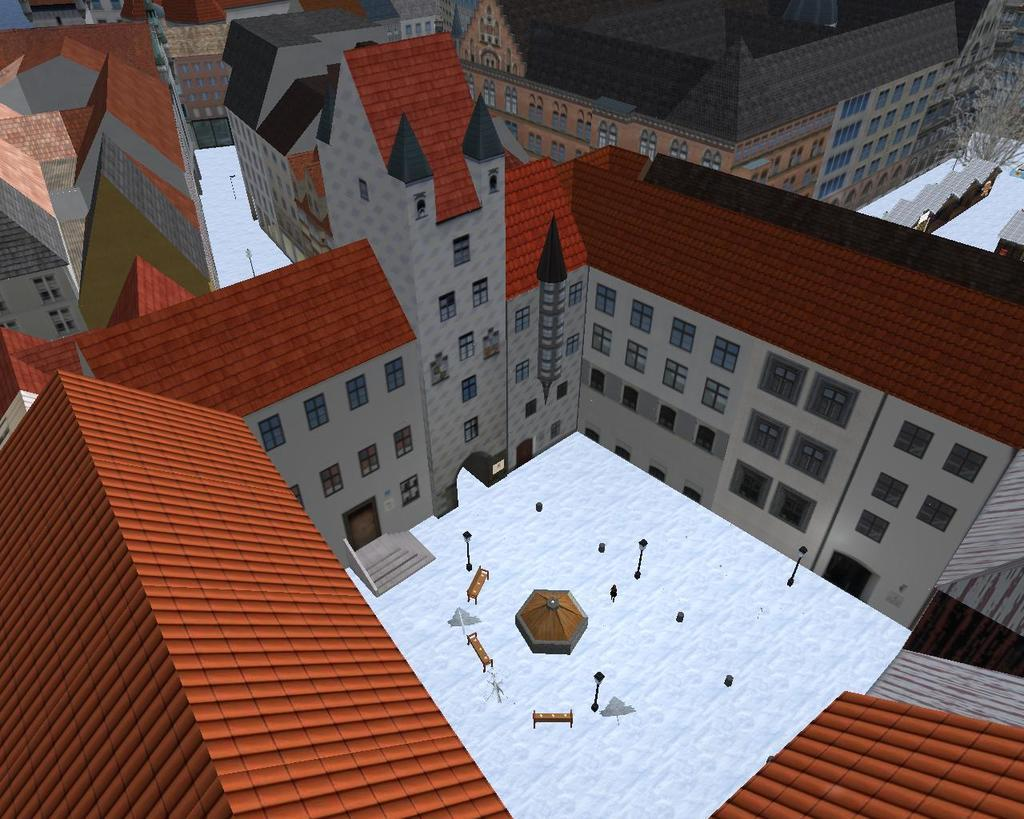What is the main subject of the image? There is a graphic in the image. What can be observed about the houses in the image? The houses have maroon and red color roofs in the image. What is the weather condition in the image? There is snow on the land in the image. What type of tail can be seen on the dog in the image? There is no dog or tail present in the image; it features a graphic with houses and snow. 